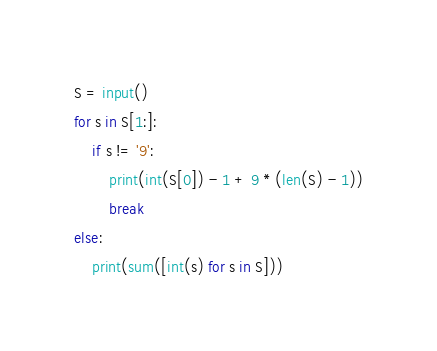<code> <loc_0><loc_0><loc_500><loc_500><_Python_>S = input()
for s in S[1:]:
    if s != '9':
        print(int(S[0]) - 1 + 9 * (len(S) - 1))
        break
else:
    print(sum([int(s) for s in S]))
</code> 